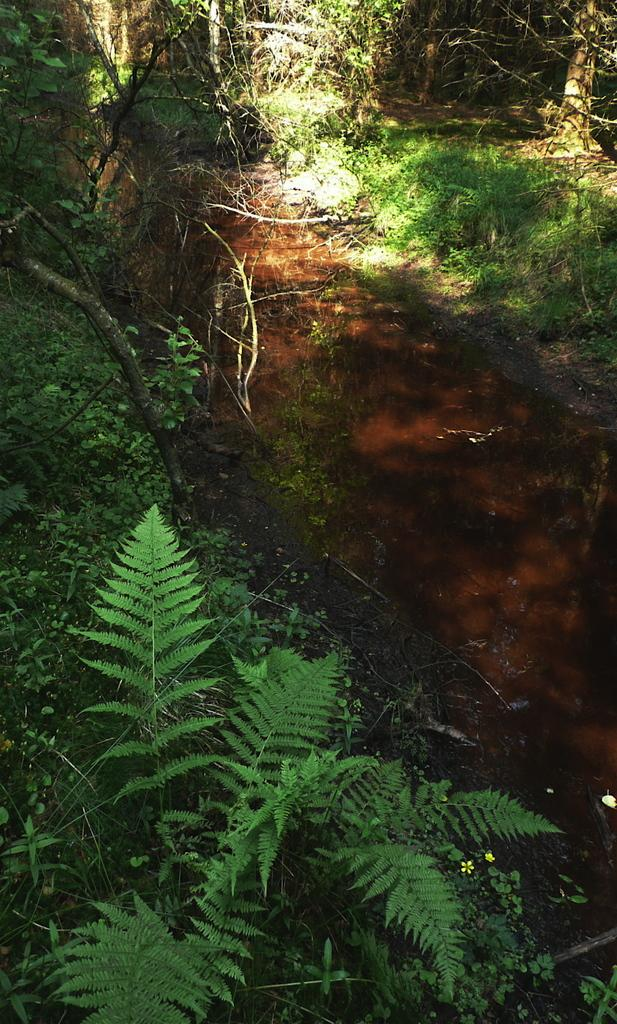What can be seen on the right side of the image? There is a path on the right side of the image. What is present alongside the path? There are many plants on both sides of the path. What type of vegetation is present in the image? There are trees in the image. How would you describe the overall setting of the image? The scene resembles a forest. How many times has the throat been folded in the image? There is no mention of a throat or folding in the image; it features a path, plants, trees, and a forest-like setting. 